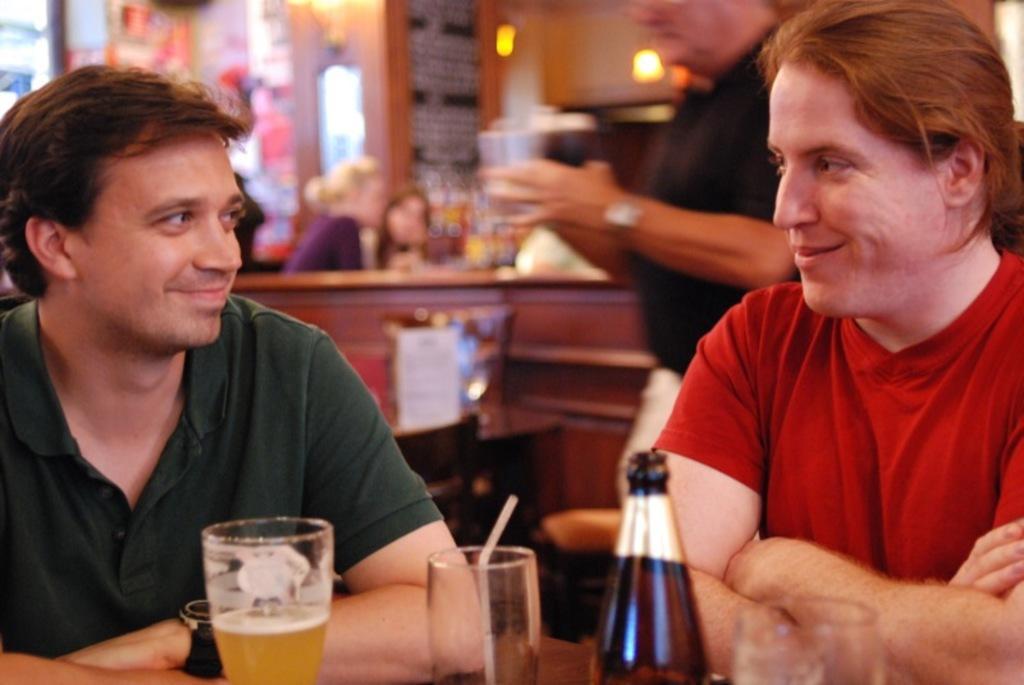In one or two sentences, can you explain what this image depicts? In this picture I can see two persons smiling, there are glasses and a bottle on the table, there are group of people, and in the background there are chairs, lights and some other objects. 